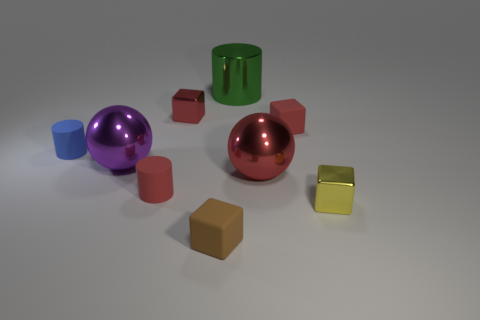There is a green shiny object that is on the left side of the tiny yellow thing; does it have the same shape as the blue rubber thing?
Offer a terse response. Yes. There is a tiny thing left of the big ball that is to the left of the red rubber object that is left of the brown object; what is its color?
Your answer should be very brief. Blue. Is there a small brown cube?
Give a very brief answer. Yes. What number of other things are the same size as the green thing?
Ensure brevity in your answer.  2. Do the large cylinder and the metal sphere on the left side of the green thing have the same color?
Offer a very short reply. No. What number of things are red metallic cylinders or small blocks?
Give a very brief answer. 4. Are there any other things that are the same color as the metal cylinder?
Your answer should be very brief. No. Is the material of the blue thing the same as the cylinder in front of the tiny blue cylinder?
Ensure brevity in your answer.  Yes. There is a large metal thing left of the tiny matte cylinder that is in front of the small blue cylinder; what is its shape?
Give a very brief answer. Sphere. There is a small rubber thing that is on the right side of the large purple ball and behind the big red metal object; what is its shape?
Offer a terse response. Cube. 